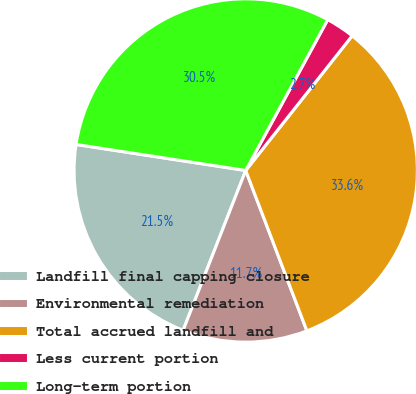<chart> <loc_0><loc_0><loc_500><loc_500><pie_chart><fcel>Landfill final capping closure<fcel>Environmental remediation<fcel>Total accrued landfill and<fcel>Less current portion<fcel>Long-term portion<nl><fcel>21.48%<fcel>11.74%<fcel>33.55%<fcel>2.72%<fcel>30.5%<nl></chart> 